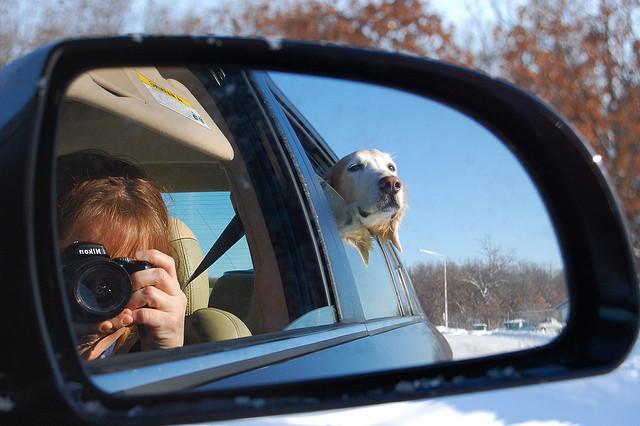Which lens used in side mirror of the car? Please explain your reasoning. convex. The mirror is convex since it slopes outward. 